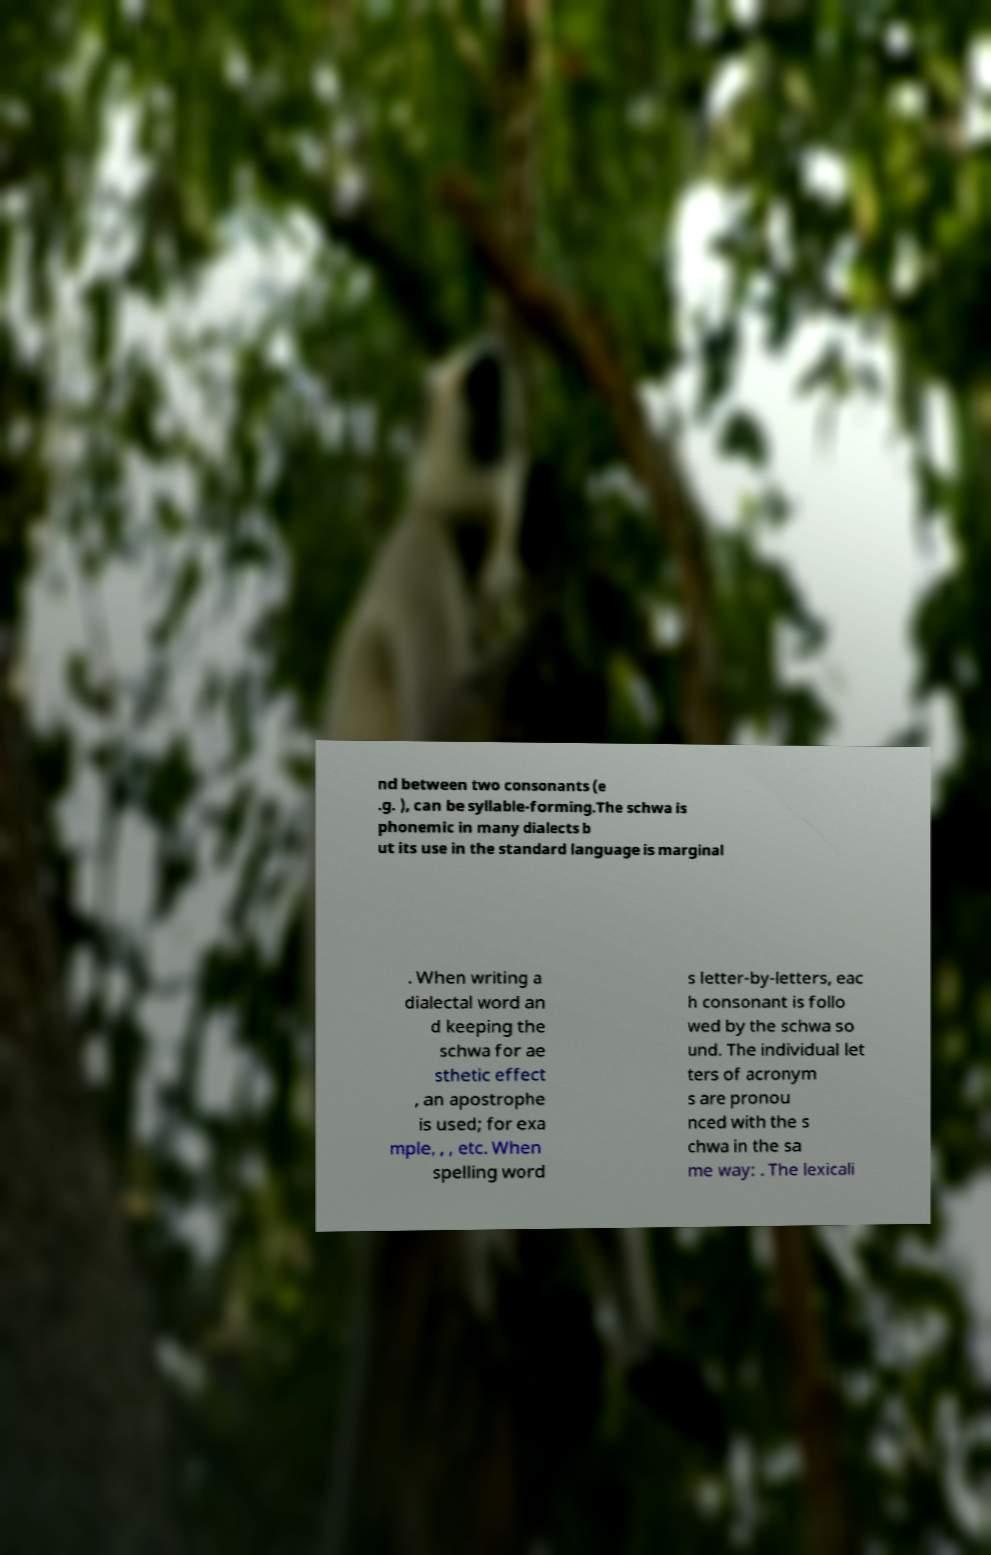I need the written content from this picture converted into text. Can you do that? nd between two consonants (e .g. ), can be syllable-forming.The schwa is phonemic in many dialects b ut its use in the standard language is marginal . When writing a dialectal word an d keeping the schwa for ae sthetic effect , an apostrophe is used; for exa mple, , , etc. When spelling word s letter-by-letters, eac h consonant is follo wed by the schwa so und. The individual let ters of acronym s are pronou nced with the s chwa in the sa me way: . The lexicali 